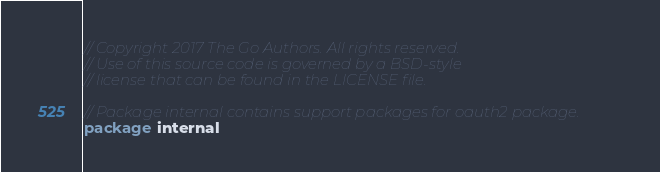Convert code to text. <code><loc_0><loc_0><loc_500><loc_500><_Go_>// Copyright 2017 The Go Authors. All rights reserved.
// Use of this source code is governed by a BSD-style
// license that can be found in the LICENSE file.

// Package internal contains support packages for oauth2 package.
package internal
</code> 